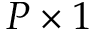<formula> <loc_0><loc_0><loc_500><loc_500>P \times 1</formula> 